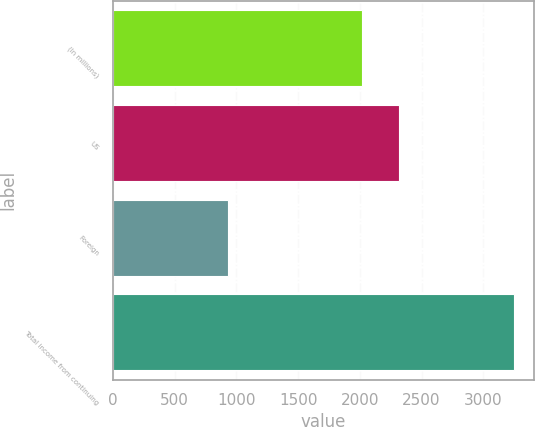<chart> <loc_0><loc_0><loc_500><loc_500><bar_chart><fcel>(In millions)<fcel>US<fcel>Foreign<fcel>Total income from continuing<nl><fcel>2016<fcel>2319<fcel>931<fcel>3250<nl></chart> 